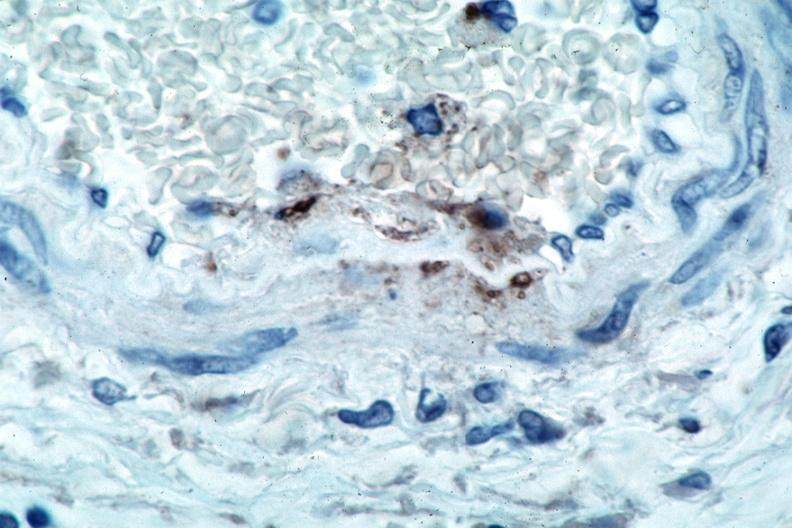what spotted fever, immunoperoxidase staining vessels for rickettsia rickettsii?
Answer the question using a single word or phrase. Rocky mountain 